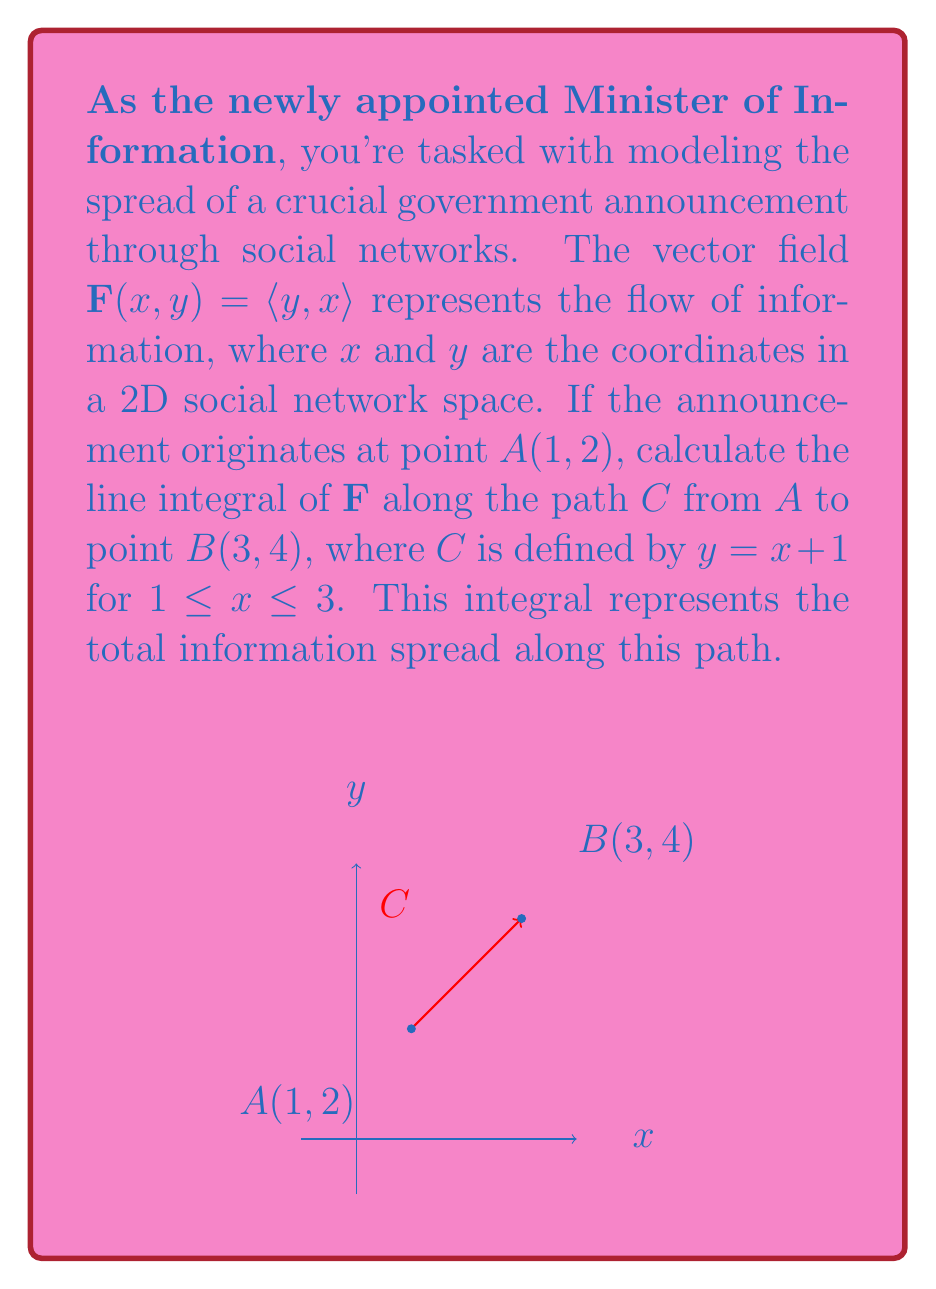Teach me how to tackle this problem. Let's approach this step-by-step:

1) The vector field is given as $\mathbf{F}(x,y) = \langle y, x \rangle$.

2) The path $C$ is defined by $y = x + 1$ for $1 \leq x \leq 3$.

3) To calculate the line integral, we use the formula:

   $$\int_C \mathbf{F} \cdot d\mathbf{r} = \int_a^b \mathbf{F}(x,y(x)) \cdot \langle 1, \frac{dy}{dx} \rangle dx$$

4) Here, $y = x + 1$, so $\frac{dy}{dx} = 1$.

5) Substituting into the formula:

   $$\int_1^3 \langle x+1, x \rangle \cdot \langle 1, 1 \rangle dx$$

6) Simplifying the dot product:

   $$\int_1^3 ((x+1) \cdot 1 + x \cdot 1) dx = \int_1^3 (2x + 1) dx$$

7) Integrating:

   $$\left[x^2 + x\right]_1^3$$

8) Evaluating the limits:

   $$(3^2 + 3) - (1^2 + 1) = (9 + 3) - (1 + 1) = 12 - 2 = 10$$

Therefore, the total information spread along this path in the social network is 10 units.
Answer: 10 units 